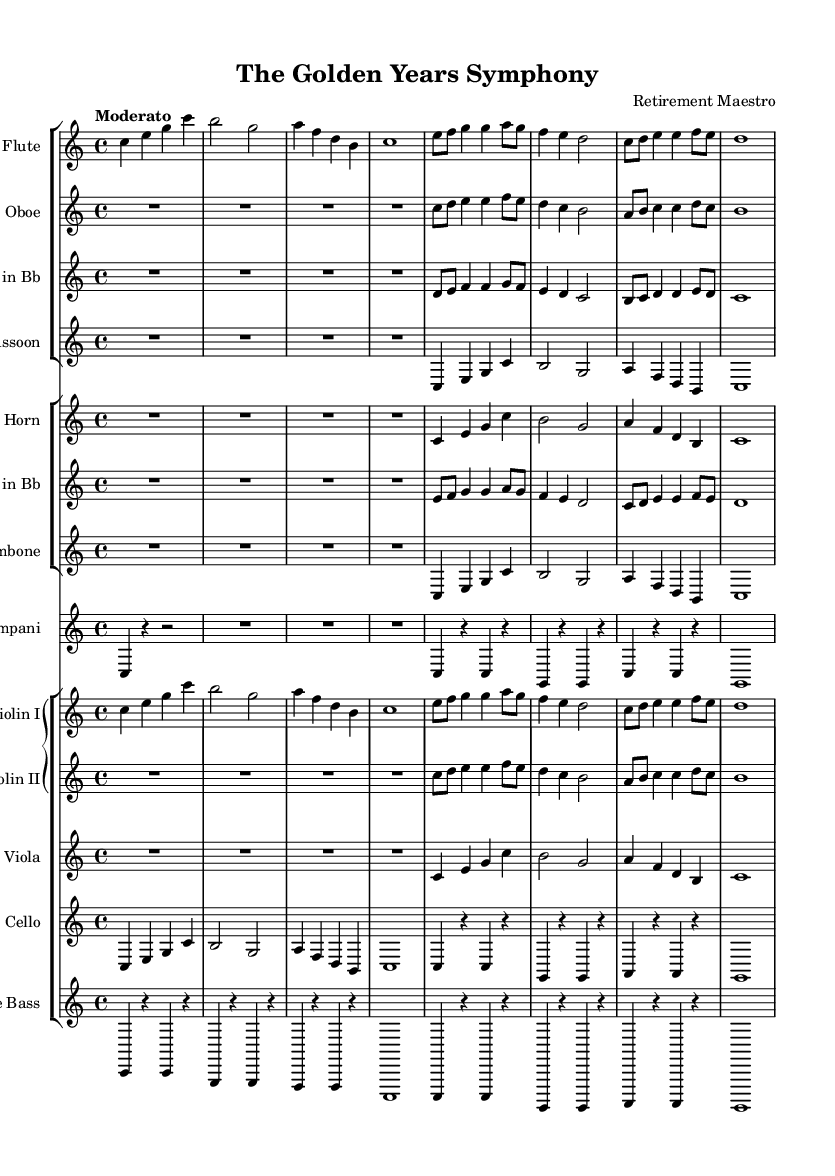What is the key signature of this music? The key signature is C major, which has no sharps or flats indicated in the music. It is derived from the global section where the key is set as `\key c \major`.
Answer: C major What is the time signature of the piece? The time signature of the piece is 4/4, as specified in the global section of the music with `\time 4/4`. This means there are four beats in a measure and the quarter note gets one beat.
Answer: 4/4 What is the tempo marking given in the score? The tempo marking in the score is indicated as "Moderato", found in the global section, where `\tempo "Moderato"` specifies a moderate pace for the performance of the piece.
Answer: Moderato How many instruments are used in the symphony? There are a total of ten instruments listed in the score. The staff groups show a combination including woodwinds, brass, percussion, and strings, which collectively make up the orchestral ensemble.
Answer: Ten Which section has the violins? The violins are located in the `GrandStaff` section of the score, where both Violin I and Violin II are notated together, indicating they play in a close grouping typically used in orchestral music.
Answer: GrandStaff How many measures are in the flute part shown? The flute part contains six measures, easily counted by looking at the individual bar lines dividing the musical notation. Each segment between the bar lines represents one measure.
Answer: Six 